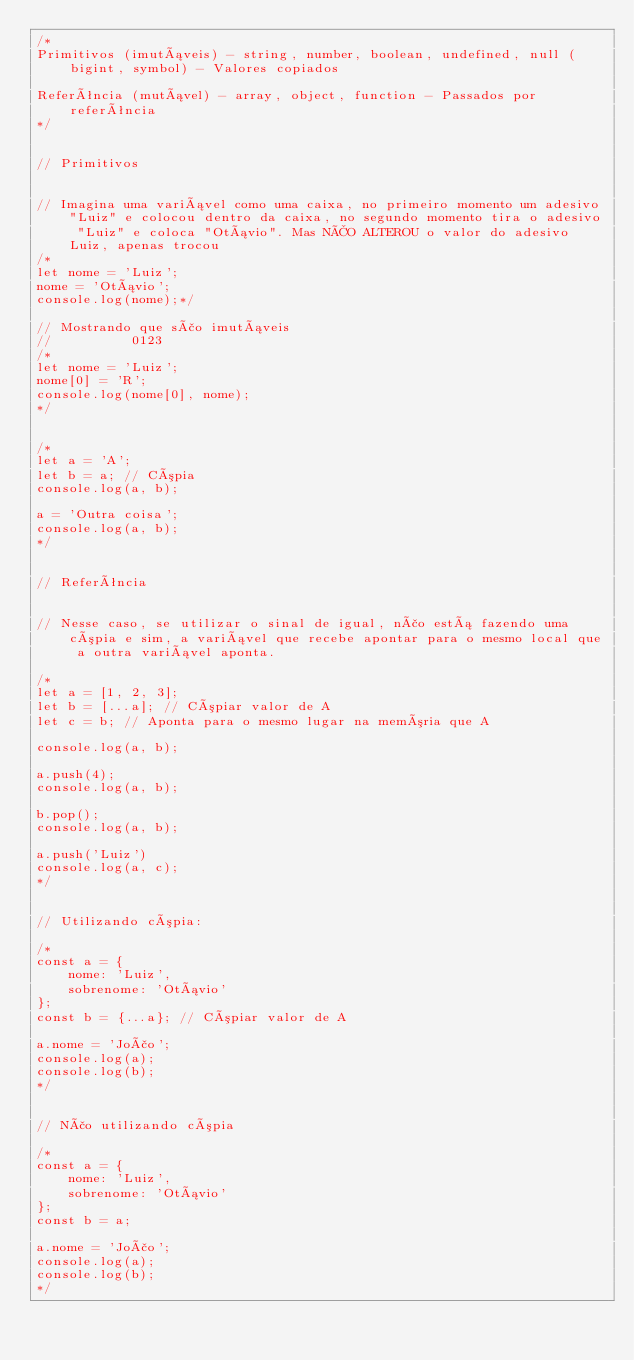<code> <loc_0><loc_0><loc_500><loc_500><_JavaScript_>/*
Primitivos (imutáveis) - string, number, boolean, undefined, null (bigint, symbol) - Valores copiados

Referência (mutável) - array, object, function - Passados por referência
*/


// Primitivos


// Imagina uma variável como uma caixa, no primeiro momento um adesivo "Luiz" e colocou dentro da caixa, no segundo momento tira o adesivo "Luiz" e coloca "Otávio". Mas NÃO ALTEROU o valor do adesivo Luiz, apenas trocou
/*
let nome = 'Luiz';
nome = 'Otávio';
console.log(nome);*/

// Mostrando que são imutáveis
//          0123
/*
let nome = 'Luiz';
nome[0] = 'R';
console.log(nome[0], nome);
*/


/*
let a = 'A';
let b = a; // Cópia
console.log(a, b);

a = 'Outra coisa';
console.log(a, b);
*/


// Referência


// Nesse caso, se utilizar o sinal de igual, não está fazendo uma cópia e sim, a variável que recebe apontar para o mesmo local que a outra variável aponta.

/*
let a = [1, 2, 3];
let b = [...a]; // Cópiar valor de A
let c = b; // Aponta para o mesmo lugar na memória que A

console.log(a, b);

a.push(4);
console.log(a, b);

b.pop();
console.log(a, b);

a.push('Luiz')
console.log(a, c);
*/


// Utilizando cópia:

/*
const a = {
    nome: 'Luiz',
    sobrenome: 'Otávio'
};
const b = {...a}; // Cópiar valor de A

a.nome = 'João';
console.log(a);
console.log(b);
*/


// Não utilizando cópia

/*
const a = {
    nome: 'Luiz',
    sobrenome: 'Otávio'
};
const b = a;

a.nome = 'João';
console.log(a);
console.log(b);
*/
</code> 